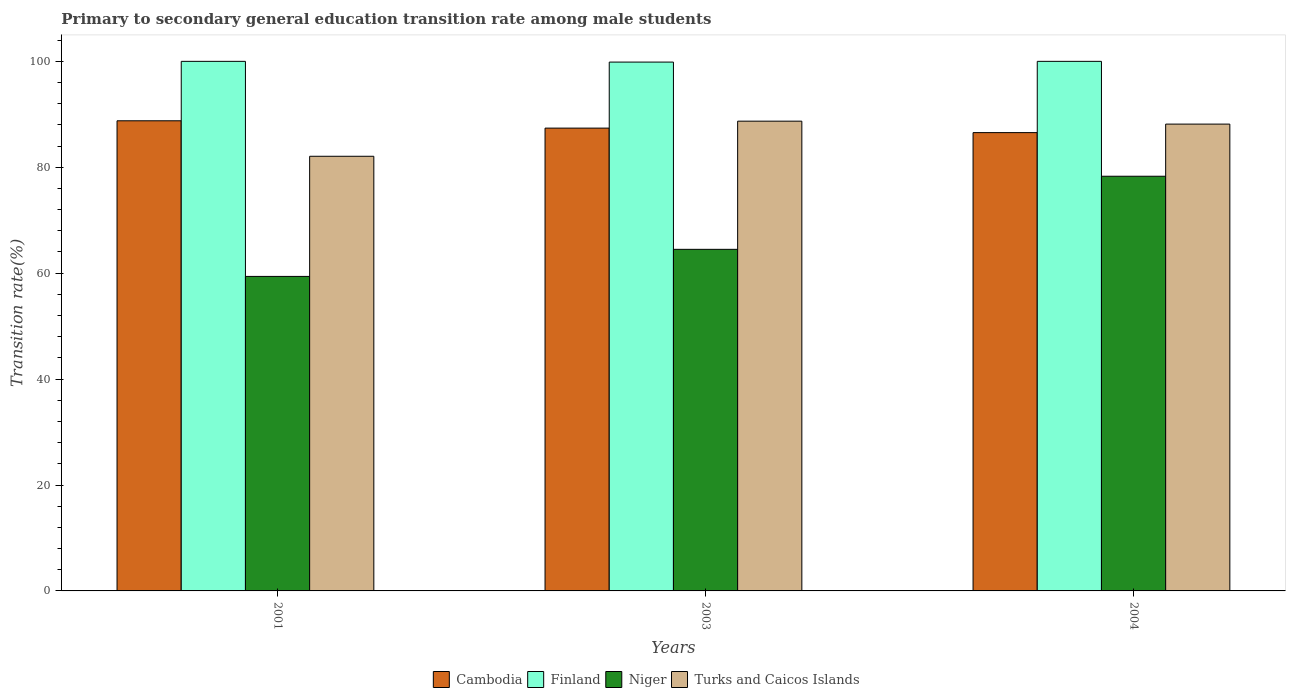How many different coloured bars are there?
Make the answer very short. 4. Are the number of bars per tick equal to the number of legend labels?
Your answer should be compact. Yes. How many bars are there on the 1st tick from the left?
Keep it short and to the point. 4. In how many cases, is the number of bars for a given year not equal to the number of legend labels?
Offer a very short reply. 0. What is the transition rate in Turks and Caicos Islands in 2003?
Your response must be concise. 88.71. Across all years, what is the maximum transition rate in Niger?
Your response must be concise. 78.3. Across all years, what is the minimum transition rate in Cambodia?
Your answer should be very brief. 86.54. In which year was the transition rate in Niger minimum?
Provide a succinct answer. 2001. What is the total transition rate in Finland in the graph?
Your answer should be very brief. 299.86. What is the difference between the transition rate in Finland in 2003 and that in 2004?
Offer a terse response. -0.14. What is the difference between the transition rate in Niger in 2003 and the transition rate in Turks and Caicos Islands in 2004?
Provide a succinct answer. -23.65. What is the average transition rate in Cambodia per year?
Make the answer very short. 87.57. In the year 2001, what is the difference between the transition rate in Niger and transition rate in Turks and Caicos Islands?
Give a very brief answer. -22.69. In how many years, is the transition rate in Niger greater than 32 %?
Keep it short and to the point. 3. What is the ratio of the transition rate in Turks and Caicos Islands in 2001 to that in 2004?
Provide a short and direct response. 0.93. Is the transition rate in Cambodia in 2001 less than that in 2003?
Provide a succinct answer. No. What is the difference between the highest and the second highest transition rate in Niger?
Your response must be concise. 13.8. What is the difference between the highest and the lowest transition rate in Turks and Caicos Islands?
Give a very brief answer. 6.63. Is the sum of the transition rate in Finland in 2001 and 2004 greater than the maximum transition rate in Cambodia across all years?
Ensure brevity in your answer.  Yes. What does the 4th bar from the left in 2001 represents?
Provide a short and direct response. Turks and Caicos Islands. What does the 3rd bar from the right in 2003 represents?
Your answer should be compact. Finland. How many bars are there?
Make the answer very short. 12. Are the values on the major ticks of Y-axis written in scientific E-notation?
Provide a short and direct response. No. Where does the legend appear in the graph?
Give a very brief answer. Bottom center. How many legend labels are there?
Give a very brief answer. 4. How are the legend labels stacked?
Keep it short and to the point. Horizontal. What is the title of the graph?
Keep it short and to the point. Primary to secondary general education transition rate among male students. What is the label or title of the X-axis?
Your response must be concise. Years. What is the label or title of the Y-axis?
Your answer should be very brief. Transition rate(%). What is the Transition rate(%) of Cambodia in 2001?
Provide a short and direct response. 88.78. What is the Transition rate(%) of Niger in 2001?
Your answer should be very brief. 59.39. What is the Transition rate(%) in Turks and Caicos Islands in 2001?
Offer a terse response. 82.08. What is the Transition rate(%) in Cambodia in 2003?
Give a very brief answer. 87.39. What is the Transition rate(%) in Finland in 2003?
Provide a succinct answer. 99.86. What is the Transition rate(%) of Niger in 2003?
Your answer should be very brief. 64.5. What is the Transition rate(%) in Turks and Caicos Islands in 2003?
Make the answer very short. 88.71. What is the Transition rate(%) in Cambodia in 2004?
Ensure brevity in your answer.  86.54. What is the Transition rate(%) of Finland in 2004?
Offer a terse response. 100. What is the Transition rate(%) in Niger in 2004?
Ensure brevity in your answer.  78.3. What is the Transition rate(%) of Turks and Caicos Islands in 2004?
Give a very brief answer. 88.15. Across all years, what is the maximum Transition rate(%) of Cambodia?
Provide a succinct answer. 88.78. Across all years, what is the maximum Transition rate(%) of Finland?
Provide a short and direct response. 100. Across all years, what is the maximum Transition rate(%) in Niger?
Provide a succinct answer. 78.3. Across all years, what is the maximum Transition rate(%) in Turks and Caicos Islands?
Make the answer very short. 88.71. Across all years, what is the minimum Transition rate(%) in Cambodia?
Offer a very short reply. 86.54. Across all years, what is the minimum Transition rate(%) in Finland?
Provide a short and direct response. 99.86. Across all years, what is the minimum Transition rate(%) of Niger?
Your response must be concise. 59.39. Across all years, what is the minimum Transition rate(%) of Turks and Caicos Islands?
Your answer should be compact. 82.08. What is the total Transition rate(%) of Cambodia in the graph?
Your response must be concise. 262.71. What is the total Transition rate(%) of Finland in the graph?
Your answer should be compact. 299.86. What is the total Transition rate(%) of Niger in the graph?
Give a very brief answer. 202.2. What is the total Transition rate(%) of Turks and Caicos Islands in the graph?
Provide a short and direct response. 258.93. What is the difference between the Transition rate(%) in Cambodia in 2001 and that in 2003?
Your response must be concise. 1.38. What is the difference between the Transition rate(%) in Finland in 2001 and that in 2003?
Give a very brief answer. 0.14. What is the difference between the Transition rate(%) of Niger in 2001 and that in 2003?
Your answer should be very brief. -5.11. What is the difference between the Transition rate(%) of Turks and Caicos Islands in 2001 and that in 2003?
Your answer should be very brief. -6.63. What is the difference between the Transition rate(%) of Cambodia in 2001 and that in 2004?
Make the answer very short. 2.23. What is the difference between the Transition rate(%) in Niger in 2001 and that in 2004?
Keep it short and to the point. -18.92. What is the difference between the Transition rate(%) in Turks and Caicos Islands in 2001 and that in 2004?
Provide a succinct answer. -6.08. What is the difference between the Transition rate(%) in Cambodia in 2003 and that in 2004?
Give a very brief answer. 0.85. What is the difference between the Transition rate(%) of Finland in 2003 and that in 2004?
Make the answer very short. -0.14. What is the difference between the Transition rate(%) in Niger in 2003 and that in 2004?
Give a very brief answer. -13.8. What is the difference between the Transition rate(%) of Turks and Caicos Islands in 2003 and that in 2004?
Your answer should be compact. 0.56. What is the difference between the Transition rate(%) in Cambodia in 2001 and the Transition rate(%) in Finland in 2003?
Your answer should be very brief. -11.08. What is the difference between the Transition rate(%) of Cambodia in 2001 and the Transition rate(%) of Niger in 2003?
Offer a very short reply. 24.27. What is the difference between the Transition rate(%) in Cambodia in 2001 and the Transition rate(%) in Turks and Caicos Islands in 2003?
Your response must be concise. 0.07. What is the difference between the Transition rate(%) of Finland in 2001 and the Transition rate(%) of Niger in 2003?
Provide a short and direct response. 35.5. What is the difference between the Transition rate(%) in Finland in 2001 and the Transition rate(%) in Turks and Caicos Islands in 2003?
Provide a succinct answer. 11.29. What is the difference between the Transition rate(%) of Niger in 2001 and the Transition rate(%) of Turks and Caicos Islands in 2003?
Ensure brevity in your answer.  -29.32. What is the difference between the Transition rate(%) of Cambodia in 2001 and the Transition rate(%) of Finland in 2004?
Keep it short and to the point. -11.22. What is the difference between the Transition rate(%) of Cambodia in 2001 and the Transition rate(%) of Niger in 2004?
Give a very brief answer. 10.47. What is the difference between the Transition rate(%) in Cambodia in 2001 and the Transition rate(%) in Turks and Caicos Islands in 2004?
Provide a short and direct response. 0.63. What is the difference between the Transition rate(%) of Finland in 2001 and the Transition rate(%) of Niger in 2004?
Make the answer very short. 21.7. What is the difference between the Transition rate(%) of Finland in 2001 and the Transition rate(%) of Turks and Caicos Islands in 2004?
Your response must be concise. 11.85. What is the difference between the Transition rate(%) in Niger in 2001 and the Transition rate(%) in Turks and Caicos Islands in 2004?
Your answer should be compact. -28.76. What is the difference between the Transition rate(%) in Cambodia in 2003 and the Transition rate(%) in Finland in 2004?
Your response must be concise. -12.61. What is the difference between the Transition rate(%) of Cambodia in 2003 and the Transition rate(%) of Niger in 2004?
Your response must be concise. 9.09. What is the difference between the Transition rate(%) of Cambodia in 2003 and the Transition rate(%) of Turks and Caicos Islands in 2004?
Ensure brevity in your answer.  -0.76. What is the difference between the Transition rate(%) of Finland in 2003 and the Transition rate(%) of Niger in 2004?
Make the answer very short. 21.56. What is the difference between the Transition rate(%) in Finland in 2003 and the Transition rate(%) in Turks and Caicos Islands in 2004?
Your response must be concise. 11.71. What is the difference between the Transition rate(%) of Niger in 2003 and the Transition rate(%) of Turks and Caicos Islands in 2004?
Provide a short and direct response. -23.65. What is the average Transition rate(%) in Cambodia per year?
Make the answer very short. 87.57. What is the average Transition rate(%) in Finland per year?
Your answer should be compact. 99.95. What is the average Transition rate(%) of Niger per year?
Make the answer very short. 67.4. What is the average Transition rate(%) in Turks and Caicos Islands per year?
Ensure brevity in your answer.  86.31. In the year 2001, what is the difference between the Transition rate(%) in Cambodia and Transition rate(%) in Finland?
Your answer should be very brief. -11.22. In the year 2001, what is the difference between the Transition rate(%) in Cambodia and Transition rate(%) in Niger?
Offer a terse response. 29.39. In the year 2001, what is the difference between the Transition rate(%) in Cambodia and Transition rate(%) in Turks and Caicos Islands?
Provide a short and direct response. 6.7. In the year 2001, what is the difference between the Transition rate(%) of Finland and Transition rate(%) of Niger?
Your answer should be very brief. 40.61. In the year 2001, what is the difference between the Transition rate(%) in Finland and Transition rate(%) in Turks and Caicos Islands?
Make the answer very short. 17.92. In the year 2001, what is the difference between the Transition rate(%) in Niger and Transition rate(%) in Turks and Caicos Islands?
Provide a short and direct response. -22.69. In the year 2003, what is the difference between the Transition rate(%) of Cambodia and Transition rate(%) of Finland?
Ensure brevity in your answer.  -12.47. In the year 2003, what is the difference between the Transition rate(%) of Cambodia and Transition rate(%) of Niger?
Provide a succinct answer. 22.89. In the year 2003, what is the difference between the Transition rate(%) in Cambodia and Transition rate(%) in Turks and Caicos Islands?
Provide a short and direct response. -1.32. In the year 2003, what is the difference between the Transition rate(%) in Finland and Transition rate(%) in Niger?
Offer a terse response. 35.36. In the year 2003, what is the difference between the Transition rate(%) of Finland and Transition rate(%) of Turks and Caicos Islands?
Make the answer very short. 11.15. In the year 2003, what is the difference between the Transition rate(%) of Niger and Transition rate(%) of Turks and Caicos Islands?
Offer a very short reply. -24.2. In the year 2004, what is the difference between the Transition rate(%) of Cambodia and Transition rate(%) of Finland?
Provide a succinct answer. -13.46. In the year 2004, what is the difference between the Transition rate(%) of Cambodia and Transition rate(%) of Niger?
Offer a terse response. 8.24. In the year 2004, what is the difference between the Transition rate(%) in Cambodia and Transition rate(%) in Turks and Caicos Islands?
Your answer should be compact. -1.61. In the year 2004, what is the difference between the Transition rate(%) in Finland and Transition rate(%) in Niger?
Your response must be concise. 21.7. In the year 2004, what is the difference between the Transition rate(%) in Finland and Transition rate(%) in Turks and Caicos Islands?
Your answer should be very brief. 11.85. In the year 2004, what is the difference between the Transition rate(%) of Niger and Transition rate(%) of Turks and Caicos Islands?
Provide a succinct answer. -9.85. What is the ratio of the Transition rate(%) in Cambodia in 2001 to that in 2003?
Offer a terse response. 1.02. What is the ratio of the Transition rate(%) in Niger in 2001 to that in 2003?
Provide a short and direct response. 0.92. What is the ratio of the Transition rate(%) in Turks and Caicos Islands in 2001 to that in 2003?
Offer a terse response. 0.93. What is the ratio of the Transition rate(%) of Cambodia in 2001 to that in 2004?
Ensure brevity in your answer.  1.03. What is the ratio of the Transition rate(%) of Finland in 2001 to that in 2004?
Your answer should be compact. 1. What is the ratio of the Transition rate(%) in Niger in 2001 to that in 2004?
Offer a terse response. 0.76. What is the ratio of the Transition rate(%) of Turks and Caicos Islands in 2001 to that in 2004?
Keep it short and to the point. 0.93. What is the ratio of the Transition rate(%) in Cambodia in 2003 to that in 2004?
Offer a very short reply. 1.01. What is the ratio of the Transition rate(%) in Niger in 2003 to that in 2004?
Your response must be concise. 0.82. What is the difference between the highest and the second highest Transition rate(%) of Cambodia?
Your answer should be compact. 1.38. What is the difference between the highest and the second highest Transition rate(%) in Niger?
Provide a succinct answer. 13.8. What is the difference between the highest and the second highest Transition rate(%) of Turks and Caicos Islands?
Ensure brevity in your answer.  0.56. What is the difference between the highest and the lowest Transition rate(%) of Cambodia?
Provide a short and direct response. 2.23. What is the difference between the highest and the lowest Transition rate(%) of Finland?
Offer a very short reply. 0.14. What is the difference between the highest and the lowest Transition rate(%) in Niger?
Offer a very short reply. 18.92. What is the difference between the highest and the lowest Transition rate(%) of Turks and Caicos Islands?
Your answer should be compact. 6.63. 